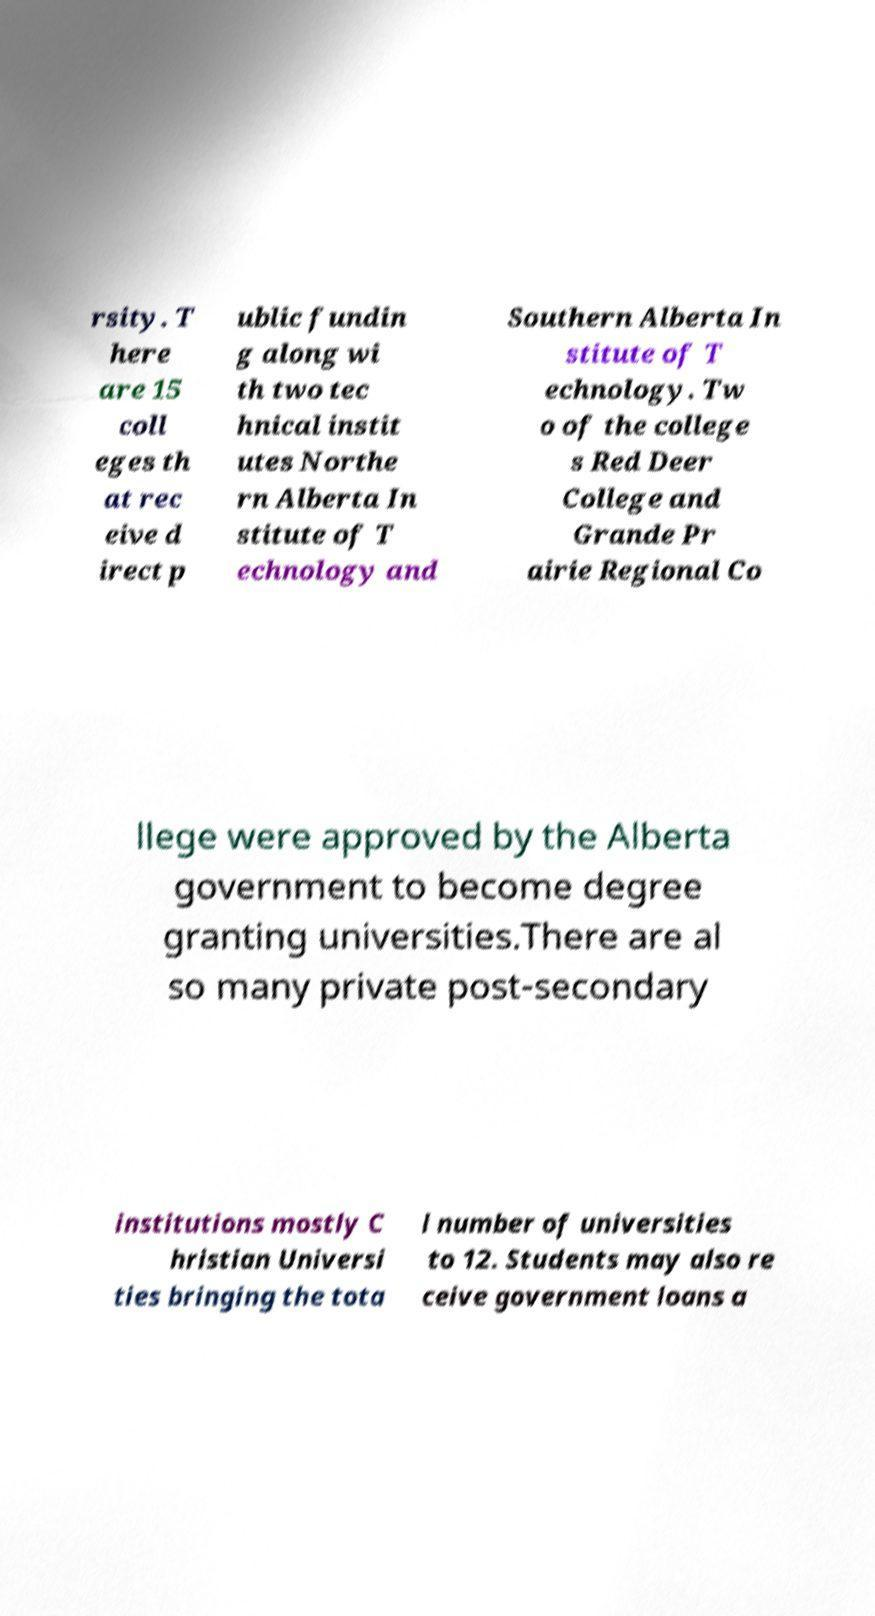I need the written content from this picture converted into text. Can you do that? rsity. T here are 15 coll eges th at rec eive d irect p ublic fundin g along wi th two tec hnical instit utes Northe rn Alberta In stitute of T echnology and Southern Alberta In stitute of T echnology. Tw o of the college s Red Deer College and Grande Pr airie Regional Co llege were approved by the Alberta government to become degree granting universities.There are al so many private post-secondary institutions mostly C hristian Universi ties bringing the tota l number of universities to 12. Students may also re ceive government loans a 